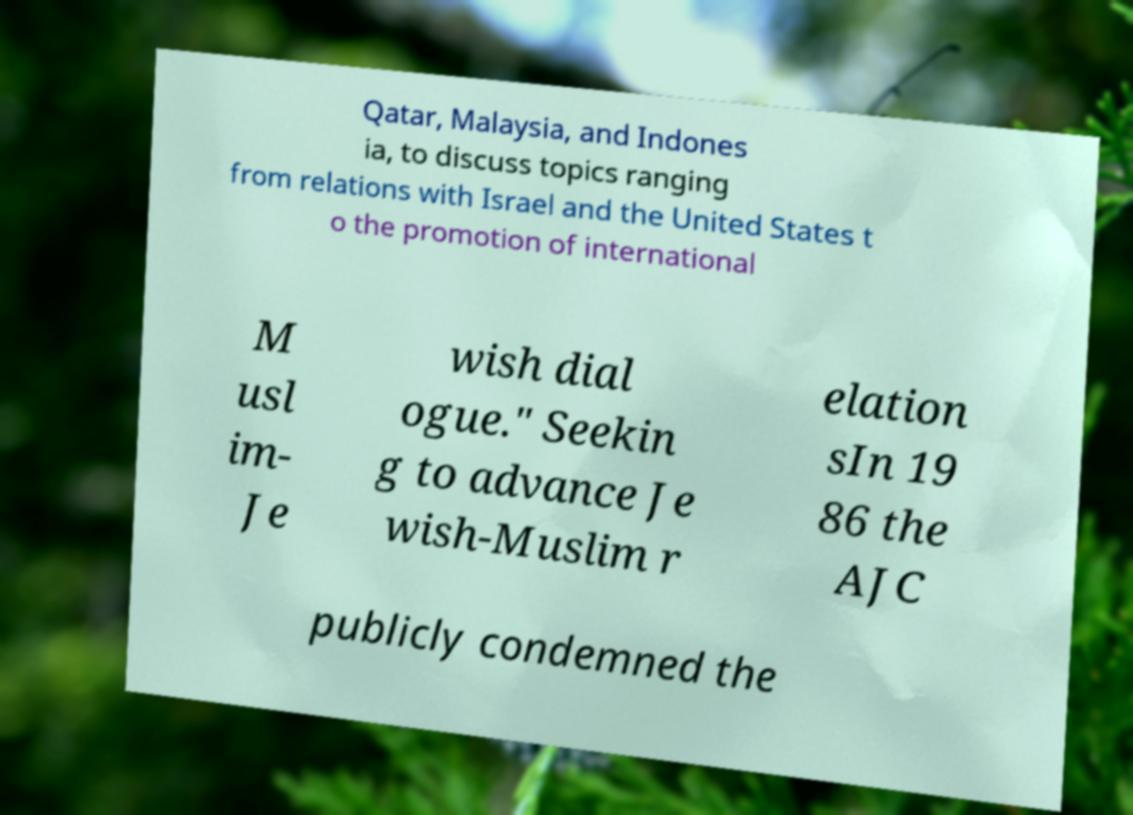What messages or text are displayed in this image? I need them in a readable, typed format. Qatar, Malaysia, and Indones ia, to discuss topics ranging from relations with Israel and the United States t o the promotion of international M usl im- Je wish dial ogue." Seekin g to advance Je wish-Muslim r elation sIn 19 86 the AJC publicly condemned the 